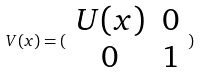<formula> <loc_0><loc_0><loc_500><loc_500>V ( x ) = ( \begin{array} { c c } U ( x ) & 0 \\ 0 & 1 \end{array} )</formula> 